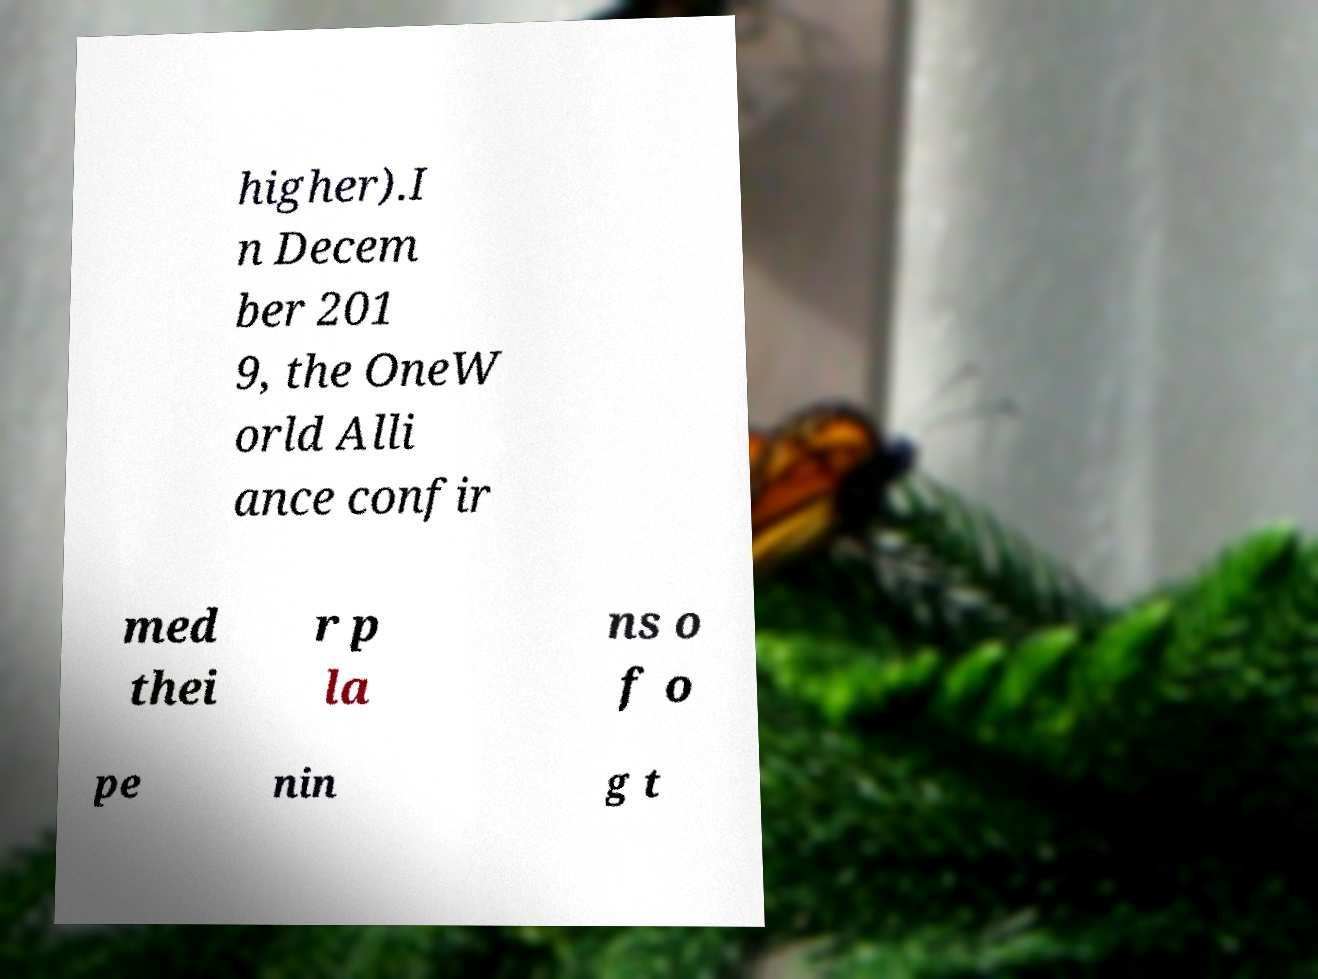What messages or text are displayed in this image? I need them in a readable, typed format. higher).I n Decem ber 201 9, the OneW orld Alli ance confir med thei r p la ns o f o pe nin g t 